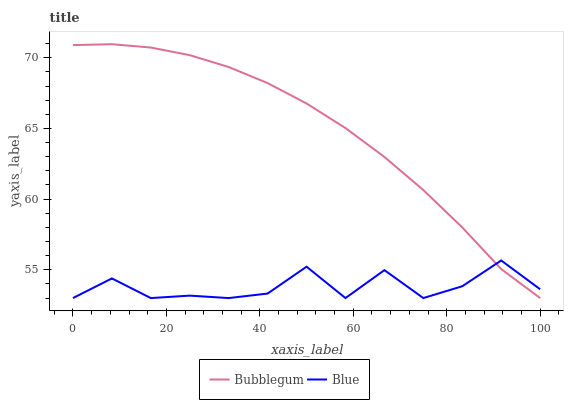Does Blue have the minimum area under the curve?
Answer yes or no. Yes. Does Bubblegum have the maximum area under the curve?
Answer yes or no. Yes. Does Bubblegum have the minimum area under the curve?
Answer yes or no. No. Is Bubblegum the smoothest?
Answer yes or no. Yes. Is Blue the roughest?
Answer yes or no. Yes. Is Bubblegum the roughest?
Answer yes or no. No. Does Blue have the lowest value?
Answer yes or no. Yes. Does Bubblegum have the highest value?
Answer yes or no. Yes. Does Blue intersect Bubblegum?
Answer yes or no. Yes. Is Blue less than Bubblegum?
Answer yes or no. No. Is Blue greater than Bubblegum?
Answer yes or no. No. 